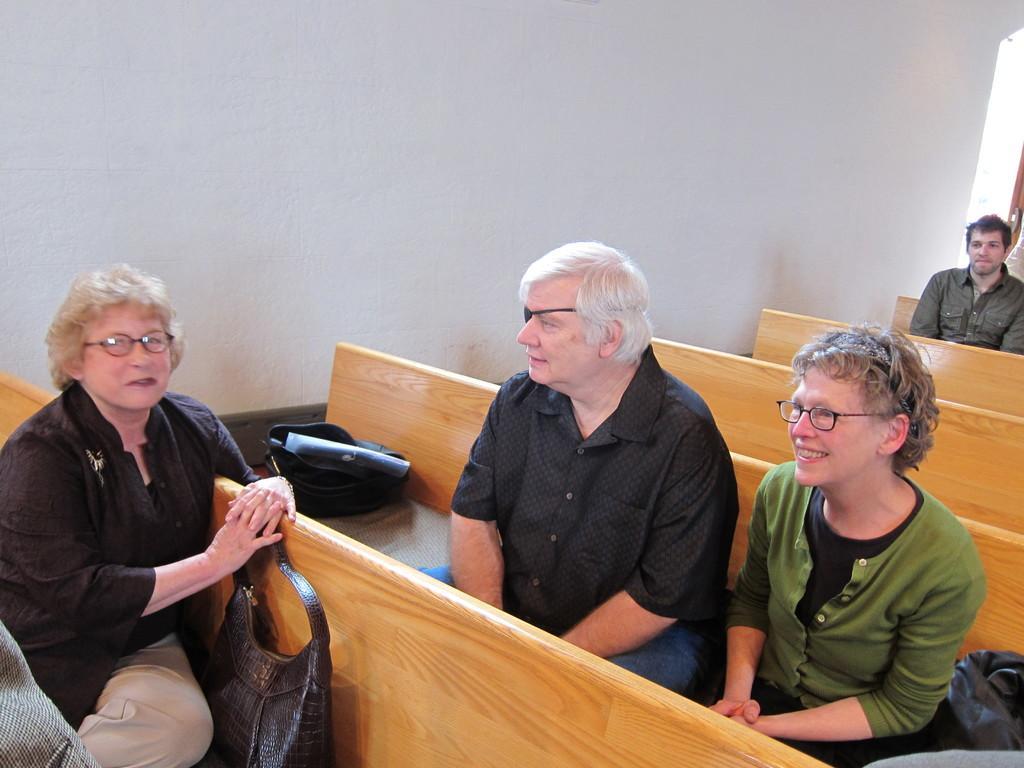Could you give a brief overview of what you see in this image? In this image we can see persons sitting on the benches. In the background there is wall. 